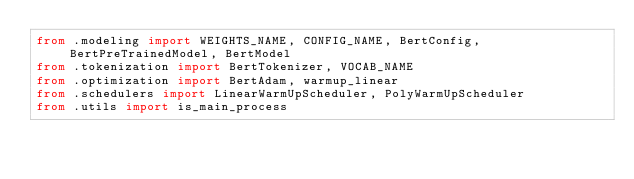Convert code to text. <code><loc_0><loc_0><loc_500><loc_500><_Python_>from .modeling import WEIGHTS_NAME, CONFIG_NAME, BertConfig, BertPreTrainedModel, BertModel
from .tokenization import BertTokenizer, VOCAB_NAME
from .optimization import BertAdam, warmup_linear
from .schedulers import LinearWarmUpScheduler, PolyWarmUpScheduler
from .utils import is_main_process</code> 